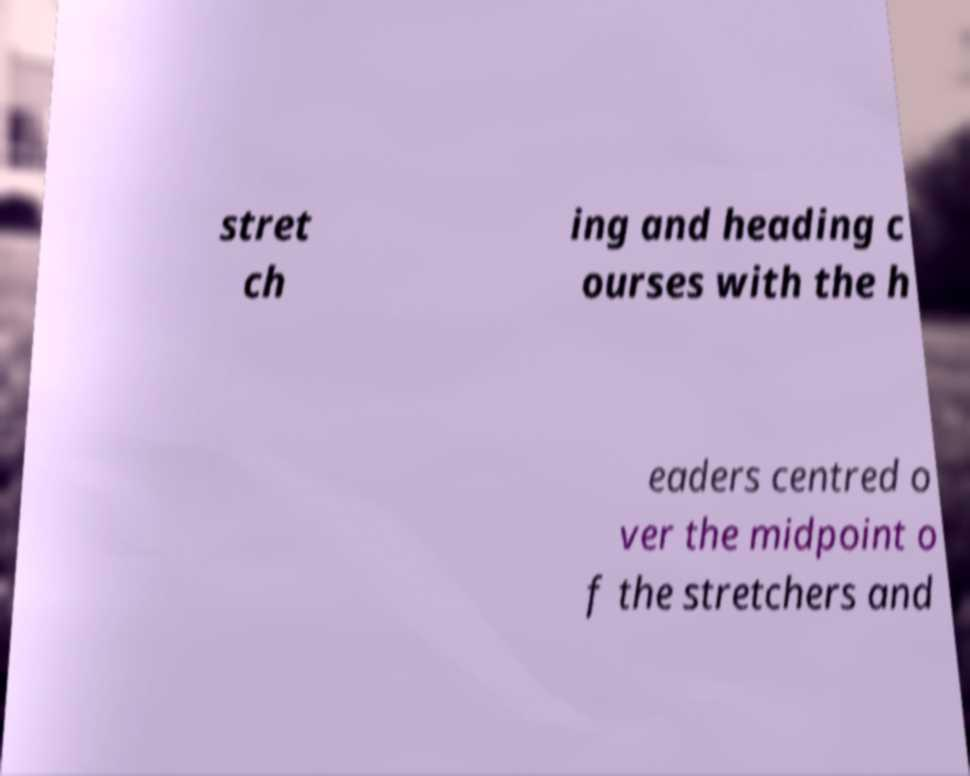Can you accurately transcribe the text from the provided image for me? stret ch ing and heading c ourses with the h eaders centred o ver the midpoint o f the stretchers and 